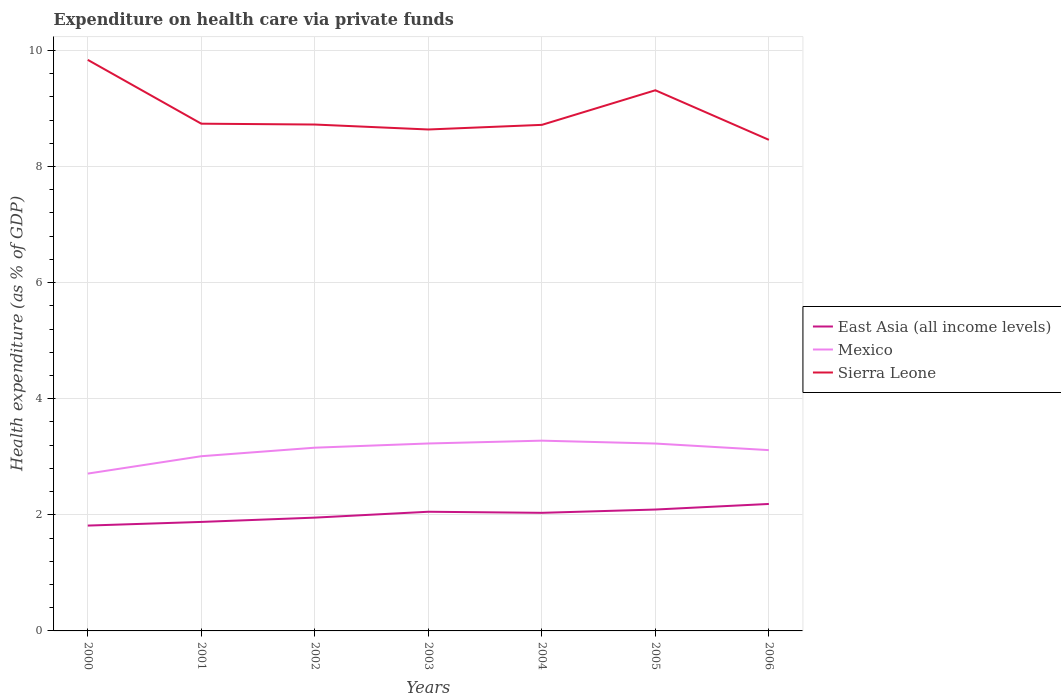How many different coloured lines are there?
Your answer should be very brief. 3. Across all years, what is the maximum expenditure made on health care in Sierra Leone?
Provide a short and direct response. 8.46. In which year was the expenditure made on health care in East Asia (all income levels) maximum?
Your response must be concise. 2000. What is the total expenditure made on health care in Sierra Leone in the graph?
Make the answer very short. -0.68. What is the difference between the highest and the second highest expenditure made on health care in Sierra Leone?
Provide a succinct answer. 1.38. How many lines are there?
Your answer should be compact. 3. Does the graph contain grids?
Offer a very short reply. Yes. Where does the legend appear in the graph?
Keep it short and to the point. Center right. How many legend labels are there?
Your answer should be compact. 3. How are the legend labels stacked?
Your answer should be very brief. Vertical. What is the title of the graph?
Provide a succinct answer. Expenditure on health care via private funds. Does "Libya" appear as one of the legend labels in the graph?
Your response must be concise. No. What is the label or title of the X-axis?
Offer a very short reply. Years. What is the label or title of the Y-axis?
Offer a very short reply. Health expenditure (as % of GDP). What is the Health expenditure (as % of GDP) of East Asia (all income levels) in 2000?
Ensure brevity in your answer.  1.81. What is the Health expenditure (as % of GDP) of Mexico in 2000?
Provide a succinct answer. 2.71. What is the Health expenditure (as % of GDP) of Sierra Leone in 2000?
Your answer should be very brief. 9.84. What is the Health expenditure (as % of GDP) of East Asia (all income levels) in 2001?
Your answer should be compact. 1.88. What is the Health expenditure (as % of GDP) in Mexico in 2001?
Offer a very short reply. 3.01. What is the Health expenditure (as % of GDP) in Sierra Leone in 2001?
Provide a short and direct response. 8.74. What is the Health expenditure (as % of GDP) in East Asia (all income levels) in 2002?
Offer a very short reply. 1.95. What is the Health expenditure (as % of GDP) in Mexico in 2002?
Your response must be concise. 3.16. What is the Health expenditure (as % of GDP) of Sierra Leone in 2002?
Give a very brief answer. 8.72. What is the Health expenditure (as % of GDP) of East Asia (all income levels) in 2003?
Your response must be concise. 2.05. What is the Health expenditure (as % of GDP) in Mexico in 2003?
Make the answer very short. 3.23. What is the Health expenditure (as % of GDP) of Sierra Leone in 2003?
Provide a succinct answer. 8.64. What is the Health expenditure (as % of GDP) in East Asia (all income levels) in 2004?
Your answer should be very brief. 2.03. What is the Health expenditure (as % of GDP) of Mexico in 2004?
Offer a terse response. 3.28. What is the Health expenditure (as % of GDP) in Sierra Leone in 2004?
Offer a very short reply. 8.72. What is the Health expenditure (as % of GDP) in East Asia (all income levels) in 2005?
Your answer should be compact. 2.09. What is the Health expenditure (as % of GDP) of Mexico in 2005?
Provide a succinct answer. 3.23. What is the Health expenditure (as % of GDP) in Sierra Leone in 2005?
Your answer should be very brief. 9.31. What is the Health expenditure (as % of GDP) of East Asia (all income levels) in 2006?
Offer a very short reply. 2.19. What is the Health expenditure (as % of GDP) in Mexico in 2006?
Your answer should be compact. 3.11. What is the Health expenditure (as % of GDP) in Sierra Leone in 2006?
Ensure brevity in your answer.  8.46. Across all years, what is the maximum Health expenditure (as % of GDP) of East Asia (all income levels)?
Your response must be concise. 2.19. Across all years, what is the maximum Health expenditure (as % of GDP) in Mexico?
Provide a succinct answer. 3.28. Across all years, what is the maximum Health expenditure (as % of GDP) of Sierra Leone?
Give a very brief answer. 9.84. Across all years, what is the minimum Health expenditure (as % of GDP) of East Asia (all income levels)?
Your answer should be compact. 1.81. Across all years, what is the minimum Health expenditure (as % of GDP) of Mexico?
Ensure brevity in your answer.  2.71. Across all years, what is the minimum Health expenditure (as % of GDP) in Sierra Leone?
Your answer should be very brief. 8.46. What is the total Health expenditure (as % of GDP) of East Asia (all income levels) in the graph?
Offer a terse response. 14.01. What is the total Health expenditure (as % of GDP) of Mexico in the graph?
Your response must be concise. 21.72. What is the total Health expenditure (as % of GDP) in Sierra Leone in the graph?
Provide a short and direct response. 62.42. What is the difference between the Health expenditure (as % of GDP) in East Asia (all income levels) in 2000 and that in 2001?
Ensure brevity in your answer.  -0.06. What is the difference between the Health expenditure (as % of GDP) in Mexico in 2000 and that in 2001?
Offer a terse response. -0.3. What is the difference between the Health expenditure (as % of GDP) in Sierra Leone in 2000 and that in 2001?
Give a very brief answer. 1.1. What is the difference between the Health expenditure (as % of GDP) in East Asia (all income levels) in 2000 and that in 2002?
Provide a short and direct response. -0.14. What is the difference between the Health expenditure (as % of GDP) of Mexico in 2000 and that in 2002?
Keep it short and to the point. -0.45. What is the difference between the Health expenditure (as % of GDP) of Sierra Leone in 2000 and that in 2002?
Make the answer very short. 1.11. What is the difference between the Health expenditure (as % of GDP) in East Asia (all income levels) in 2000 and that in 2003?
Ensure brevity in your answer.  -0.24. What is the difference between the Health expenditure (as % of GDP) of Mexico in 2000 and that in 2003?
Ensure brevity in your answer.  -0.52. What is the difference between the Health expenditure (as % of GDP) of Sierra Leone in 2000 and that in 2003?
Offer a terse response. 1.2. What is the difference between the Health expenditure (as % of GDP) of East Asia (all income levels) in 2000 and that in 2004?
Provide a short and direct response. -0.22. What is the difference between the Health expenditure (as % of GDP) in Mexico in 2000 and that in 2004?
Ensure brevity in your answer.  -0.57. What is the difference between the Health expenditure (as % of GDP) of Sierra Leone in 2000 and that in 2004?
Make the answer very short. 1.12. What is the difference between the Health expenditure (as % of GDP) of East Asia (all income levels) in 2000 and that in 2005?
Your answer should be very brief. -0.28. What is the difference between the Health expenditure (as % of GDP) in Mexico in 2000 and that in 2005?
Your response must be concise. -0.52. What is the difference between the Health expenditure (as % of GDP) in Sierra Leone in 2000 and that in 2005?
Your answer should be compact. 0.52. What is the difference between the Health expenditure (as % of GDP) of East Asia (all income levels) in 2000 and that in 2006?
Offer a very short reply. -0.37. What is the difference between the Health expenditure (as % of GDP) of Mexico in 2000 and that in 2006?
Provide a short and direct response. -0.4. What is the difference between the Health expenditure (as % of GDP) of Sierra Leone in 2000 and that in 2006?
Your answer should be compact. 1.38. What is the difference between the Health expenditure (as % of GDP) of East Asia (all income levels) in 2001 and that in 2002?
Give a very brief answer. -0.07. What is the difference between the Health expenditure (as % of GDP) in Mexico in 2001 and that in 2002?
Offer a very short reply. -0.15. What is the difference between the Health expenditure (as % of GDP) in Sierra Leone in 2001 and that in 2002?
Provide a succinct answer. 0.01. What is the difference between the Health expenditure (as % of GDP) in East Asia (all income levels) in 2001 and that in 2003?
Offer a terse response. -0.18. What is the difference between the Health expenditure (as % of GDP) in Mexico in 2001 and that in 2003?
Keep it short and to the point. -0.22. What is the difference between the Health expenditure (as % of GDP) of Sierra Leone in 2001 and that in 2003?
Your answer should be compact. 0.1. What is the difference between the Health expenditure (as % of GDP) of East Asia (all income levels) in 2001 and that in 2004?
Make the answer very short. -0.16. What is the difference between the Health expenditure (as % of GDP) in Mexico in 2001 and that in 2004?
Provide a succinct answer. -0.27. What is the difference between the Health expenditure (as % of GDP) in Sierra Leone in 2001 and that in 2004?
Your answer should be very brief. 0.02. What is the difference between the Health expenditure (as % of GDP) of East Asia (all income levels) in 2001 and that in 2005?
Ensure brevity in your answer.  -0.21. What is the difference between the Health expenditure (as % of GDP) of Mexico in 2001 and that in 2005?
Ensure brevity in your answer.  -0.22. What is the difference between the Health expenditure (as % of GDP) of Sierra Leone in 2001 and that in 2005?
Provide a short and direct response. -0.58. What is the difference between the Health expenditure (as % of GDP) of East Asia (all income levels) in 2001 and that in 2006?
Your response must be concise. -0.31. What is the difference between the Health expenditure (as % of GDP) in Mexico in 2001 and that in 2006?
Provide a succinct answer. -0.1. What is the difference between the Health expenditure (as % of GDP) of Sierra Leone in 2001 and that in 2006?
Offer a terse response. 0.28. What is the difference between the Health expenditure (as % of GDP) of East Asia (all income levels) in 2002 and that in 2003?
Ensure brevity in your answer.  -0.1. What is the difference between the Health expenditure (as % of GDP) in Mexico in 2002 and that in 2003?
Make the answer very short. -0.07. What is the difference between the Health expenditure (as % of GDP) in Sierra Leone in 2002 and that in 2003?
Ensure brevity in your answer.  0.09. What is the difference between the Health expenditure (as % of GDP) in East Asia (all income levels) in 2002 and that in 2004?
Offer a terse response. -0.08. What is the difference between the Health expenditure (as % of GDP) of Mexico in 2002 and that in 2004?
Make the answer very short. -0.12. What is the difference between the Health expenditure (as % of GDP) in Sierra Leone in 2002 and that in 2004?
Offer a very short reply. 0.01. What is the difference between the Health expenditure (as % of GDP) in East Asia (all income levels) in 2002 and that in 2005?
Your answer should be very brief. -0.14. What is the difference between the Health expenditure (as % of GDP) of Mexico in 2002 and that in 2005?
Your answer should be compact. -0.07. What is the difference between the Health expenditure (as % of GDP) of Sierra Leone in 2002 and that in 2005?
Provide a short and direct response. -0.59. What is the difference between the Health expenditure (as % of GDP) in East Asia (all income levels) in 2002 and that in 2006?
Offer a terse response. -0.24. What is the difference between the Health expenditure (as % of GDP) in Mexico in 2002 and that in 2006?
Ensure brevity in your answer.  0.04. What is the difference between the Health expenditure (as % of GDP) of Sierra Leone in 2002 and that in 2006?
Your response must be concise. 0.26. What is the difference between the Health expenditure (as % of GDP) of East Asia (all income levels) in 2003 and that in 2004?
Your answer should be very brief. 0.02. What is the difference between the Health expenditure (as % of GDP) in Mexico in 2003 and that in 2004?
Provide a short and direct response. -0.05. What is the difference between the Health expenditure (as % of GDP) in Sierra Leone in 2003 and that in 2004?
Your response must be concise. -0.08. What is the difference between the Health expenditure (as % of GDP) of East Asia (all income levels) in 2003 and that in 2005?
Ensure brevity in your answer.  -0.04. What is the difference between the Health expenditure (as % of GDP) in Mexico in 2003 and that in 2005?
Your answer should be very brief. 0. What is the difference between the Health expenditure (as % of GDP) of Sierra Leone in 2003 and that in 2005?
Offer a very short reply. -0.68. What is the difference between the Health expenditure (as % of GDP) of East Asia (all income levels) in 2003 and that in 2006?
Your answer should be compact. -0.13. What is the difference between the Health expenditure (as % of GDP) in Mexico in 2003 and that in 2006?
Keep it short and to the point. 0.11. What is the difference between the Health expenditure (as % of GDP) of Sierra Leone in 2003 and that in 2006?
Give a very brief answer. 0.18. What is the difference between the Health expenditure (as % of GDP) of East Asia (all income levels) in 2004 and that in 2005?
Offer a very short reply. -0.06. What is the difference between the Health expenditure (as % of GDP) of Mexico in 2004 and that in 2005?
Ensure brevity in your answer.  0.05. What is the difference between the Health expenditure (as % of GDP) in Sierra Leone in 2004 and that in 2005?
Give a very brief answer. -0.6. What is the difference between the Health expenditure (as % of GDP) in East Asia (all income levels) in 2004 and that in 2006?
Provide a succinct answer. -0.15. What is the difference between the Health expenditure (as % of GDP) of Mexico in 2004 and that in 2006?
Make the answer very short. 0.16. What is the difference between the Health expenditure (as % of GDP) in Sierra Leone in 2004 and that in 2006?
Your response must be concise. 0.26. What is the difference between the Health expenditure (as % of GDP) of East Asia (all income levels) in 2005 and that in 2006?
Your response must be concise. -0.1. What is the difference between the Health expenditure (as % of GDP) in Mexico in 2005 and that in 2006?
Offer a very short reply. 0.11. What is the difference between the Health expenditure (as % of GDP) of Sierra Leone in 2005 and that in 2006?
Provide a succinct answer. 0.85. What is the difference between the Health expenditure (as % of GDP) in East Asia (all income levels) in 2000 and the Health expenditure (as % of GDP) in Mexico in 2001?
Give a very brief answer. -1.19. What is the difference between the Health expenditure (as % of GDP) in East Asia (all income levels) in 2000 and the Health expenditure (as % of GDP) in Sierra Leone in 2001?
Give a very brief answer. -6.92. What is the difference between the Health expenditure (as % of GDP) of Mexico in 2000 and the Health expenditure (as % of GDP) of Sierra Leone in 2001?
Ensure brevity in your answer.  -6.03. What is the difference between the Health expenditure (as % of GDP) of East Asia (all income levels) in 2000 and the Health expenditure (as % of GDP) of Mexico in 2002?
Give a very brief answer. -1.34. What is the difference between the Health expenditure (as % of GDP) in East Asia (all income levels) in 2000 and the Health expenditure (as % of GDP) in Sierra Leone in 2002?
Your response must be concise. -6.91. What is the difference between the Health expenditure (as % of GDP) in Mexico in 2000 and the Health expenditure (as % of GDP) in Sierra Leone in 2002?
Keep it short and to the point. -6.01. What is the difference between the Health expenditure (as % of GDP) in East Asia (all income levels) in 2000 and the Health expenditure (as % of GDP) in Mexico in 2003?
Your answer should be compact. -1.41. What is the difference between the Health expenditure (as % of GDP) in East Asia (all income levels) in 2000 and the Health expenditure (as % of GDP) in Sierra Leone in 2003?
Provide a short and direct response. -6.82. What is the difference between the Health expenditure (as % of GDP) in Mexico in 2000 and the Health expenditure (as % of GDP) in Sierra Leone in 2003?
Your answer should be very brief. -5.93. What is the difference between the Health expenditure (as % of GDP) of East Asia (all income levels) in 2000 and the Health expenditure (as % of GDP) of Mexico in 2004?
Give a very brief answer. -1.46. What is the difference between the Health expenditure (as % of GDP) of East Asia (all income levels) in 2000 and the Health expenditure (as % of GDP) of Sierra Leone in 2004?
Provide a short and direct response. -6.9. What is the difference between the Health expenditure (as % of GDP) in Mexico in 2000 and the Health expenditure (as % of GDP) in Sierra Leone in 2004?
Ensure brevity in your answer.  -6.01. What is the difference between the Health expenditure (as % of GDP) of East Asia (all income levels) in 2000 and the Health expenditure (as % of GDP) of Mexico in 2005?
Make the answer very short. -1.41. What is the difference between the Health expenditure (as % of GDP) of East Asia (all income levels) in 2000 and the Health expenditure (as % of GDP) of Sierra Leone in 2005?
Offer a very short reply. -7.5. What is the difference between the Health expenditure (as % of GDP) of Mexico in 2000 and the Health expenditure (as % of GDP) of Sierra Leone in 2005?
Provide a succinct answer. -6.6. What is the difference between the Health expenditure (as % of GDP) of East Asia (all income levels) in 2000 and the Health expenditure (as % of GDP) of Mexico in 2006?
Your answer should be very brief. -1.3. What is the difference between the Health expenditure (as % of GDP) in East Asia (all income levels) in 2000 and the Health expenditure (as % of GDP) in Sierra Leone in 2006?
Give a very brief answer. -6.64. What is the difference between the Health expenditure (as % of GDP) in Mexico in 2000 and the Health expenditure (as % of GDP) in Sierra Leone in 2006?
Provide a short and direct response. -5.75. What is the difference between the Health expenditure (as % of GDP) in East Asia (all income levels) in 2001 and the Health expenditure (as % of GDP) in Mexico in 2002?
Provide a short and direct response. -1.28. What is the difference between the Health expenditure (as % of GDP) in East Asia (all income levels) in 2001 and the Health expenditure (as % of GDP) in Sierra Leone in 2002?
Your response must be concise. -6.84. What is the difference between the Health expenditure (as % of GDP) of Mexico in 2001 and the Health expenditure (as % of GDP) of Sierra Leone in 2002?
Offer a very short reply. -5.71. What is the difference between the Health expenditure (as % of GDP) of East Asia (all income levels) in 2001 and the Health expenditure (as % of GDP) of Mexico in 2003?
Your response must be concise. -1.35. What is the difference between the Health expenditure (as % of GDP) of East Asia (all income levels) in 2001 and the Health expenditure (as % of GDP) of Sierra Leone in 2003?
Your answer should be compact. -6.76. What is the difference between the Health expenditure (as % of GDP) in Mexico in 2001 and the Health expenditure (as % of GDP) in Sierra Leone in 2003?
Your answer should be compact. -5.63. What is the difference between the Health expenditure (as % of GDP) in East Asia (all income levels) in 2001 and the Health expenditure (as % of GDP) in Mexico in 2004?
Give a very brief answer. -1.4. What is the difference between the Health expenditure (as % of GDP) in East Asia (all income levels) in 2001 and the Health expenditure (as % of GDP) in Sierra Leone in 2004?
Give a very brief answer. -6.84. What is the difference between the Health expenditure (as % of GDP) of Mexico in 2001 and the Health expenditure (as % of GDP) of Sierra Leone in 2004?
Provide a succinct answer. -5.71. What is the difference between the Health expenditure (as % of GDP) of East Asia (all income levels) in 2001 and the Health expenditure (as % of GDP) of Mexico in 2005?
Give a very brief answer. -1.35. What is the difference between the Health expenditure (as % of GDP) in East Asia (all income levels) in 2001 and the Health expenditure (as % of GDP) in Sierra Leone in 2005?
Your answer should be very brief. -7.43. What is the difference between the Health expenditure (as % of GDP) of Mexico in 2001 and the Health expenditure (as % of GDP) of Sierra Leone in 2005?
Ensure brevity in your answer.  -6.3. What is the difference between the Health expenditure (as % of GDP) in East Asia (all income levels) in 2001 and the Health expenditure (as % of GDP) in Mexico in 2006?
Your answer should be compact. -1.24. What is the difference between the Health expenditure (as % of GDP) in East Asia (all income levels) in 2001 and the Health expenditure (as % of GDP) in Sierra Leone in 2006?
Keep it short and to the point. -6.58. What is the difference between the Health expenditure (as % of GDP) of Mexico in 2001 and the Health expenditure (as % of GDP) of Sierra Leone in 2006?
Your answer should be very brief. -5.45. What is the difference between the Health expenditure (as % of GDP) in East Asia (all income levels) in 2002 and the Health expenditure (as % of GDP) in Mexico in 2003?
Keep it short and to the point. -1.28. What is the difference between the Health expenditure (as % of GDP) in East Asia (all income levels) in 2002 and the Health expenditure (as % of GDP) in Sierra Leone in 2003?
Provide a succinct answer. -6.69. What is the difference between the Health expenditure (as % of GDP) of Mexico in 2002 and the Health expenditure (as % of GDP) of Sierra Leone in 2003?
Offer a terse response. -5.48. What is the difference between the Health expenditure (as % of GDP) of East Asia (all income levels) in 2002 and the Health expenditure (as % of GDP) of Mexico in 2004?
Your answer should be compact. -1.33. What is the difference between the Health expenditure (as % of GDP) in East Asia (all income levels) in 2002 and the Health expenditure (as % of GDP) in Sierra Leone in 2004?
Ensure brevity in your answer.  -6.76. What is the difference between the Health expenditure (as % of GDP) of Mexico in 2002 and the Health expenditure (as % of GDP) of Sierra Leone in 2004?
Give a very brief answer. -5.56. What is the difference between the Health expenditure (as % of GDP) of East Asia (all income levels) in 2002 and the Health expenditure (as % of GDP) of Mexico in 2005?
Keep it short and to the point. -1.28. What is the difference between the Health expenditure (as % of GDP) in East Asia (all income levels) in 2002 and the Health expenditure (as % of GDP) in Sierra Leone in 2005?
Your answer should be very brief. -7.36. What is the difference between the Health expenditure (as % of GDP) of Mexico in 2002 and the Health expenditure (as % of GDP) of Sierra Leone in 2005?
Provide a short and direct response. -6.16. What is the difference between the Health expenditure (as % of GDP) in East Asia (all income levels) in 2002 and the Health expenditure (as % of GDP) in Mexico in 2006?
Provide a short and direct response. -1.16. What is the difference between the Health expenditure (as % of GDP) in East Asia (all income levels) in 2002 and the Health expenditure (as % of GDP) in Sierra Leone in 2006?
Offer a very short reply. -6.51. What is the difference between the Health expenditure (as % of GDP) in Mexico in 2002 and the Health expenditure (as % of GDP) in Sierra Leone in 2006?
Your answer should be compact. -5.3. What is the difference between the Health expenditure (as % of GDP) of East Asia (all income levels) in 2003 and the Health expenditure (as % of GDP) of Mexico in 2004?
Your answer should be very brief. -1.22. What is the difference between the Health expenditure (as % of GDP) of East Asia (all income levels) in 2003 and the Health expenditure (as % of GDP) of Sierra Leone in 2004?
Make the answer very short. -6.66. What is the difference between the Health expenditure (as % of GDP) of Mexico in 2003 and the Health expenditure (as % of GDP) of Sierra Leone in 2004?
Your response must be concise. -5.49. What is the difference between the Health expenditure (as % of GDP) of East Asia (all income levels) in 2003 and the Health expenditure (as % of GDP) of Mexico in 2005?
Give a very brief answer. -1.17. What is the difference between the Health expenditure (as % of GDP) in East Asia (all income levels) in 2003 and the Health expenditure (as % of GDP) in Sierra Leone in 2005?
Make the answer very short. -7.26. What is the difference between the Health expenditure (as % of GDP) of Mexico in 2003 and the Health expenditure (as % of GDP) of Sierra Leone in 2005?
Your response must be concise. -6.08. What is the difference between the Health expenditure (as % of GDP) of East Asia (all income levels) in 2003 and the Health expenditure (as % of GDP) of Mexico in 2006?
Your response must be concise. -1.06. What is the difference between the Health expenditure (as % of GDP) of East Asia (all income levels) in 2003 and the Health expenditure (as % of GDP) of Sierra Leone in 2006?
Keep it short and to the point. -6.41. What is the difference between the Health expenditure (as % of GDP) of Mexico in 2003 and the Health expenditure (as % of GDP) of Sierra Leone in 2006?
Offer a terse response. -5.23. What is the difference between the Health expenditure (as % of GDP) in East Asia (all income levels) in 2004 and the Health expenditure (as % of GDP) in Mexico in 2005?
Your response must be concise. -1.19. What is the difference between the Health expenditure (as % of GDP) of East Asia (all income levels) in 2004 and the Health expenditure (as % of GDP) of Sierra Leone in 2005?
Offer a very short reply. -7.28. What is the difference between the Health expenditure (as % of GDP) of Mexico in 2004 and the Health expenditure (as % of GDP) of Sierra Leone in 2005?
Your answer should be very brief. -6.04. What is the difference between the Health expenditure (as % of GDP) of East Asia (all income levels) in 2004 and the Health expenditure (as % of GDP) of Mexico in 2006?
Offer a terse response. -1.08. What is the difference between the Health expenditure (as % of GDP) in East Asia (all income levels) in 2004 and the Health expenditure (as % of GDP) in Sierra Leone in 2006?
Provide a short and direct response. -6.42. What is the difference between the Health expenditure (as % of GDP) of Mexico in 2004 and the Health expenditure (as % of GDP) of Sierra Leone in 2006?
Make the answer very short. -5.18. What is the difference between the Health expenditure (as % of GDP) of East Asia (all income levels) in 2005 and the Health expenditure (as % of GDP) of Mexico in 2006?
Offer a terse response. -1.02. What is the difference between the Health expenditure (as % of GDP) in East Asia (all income levels) in 2005 and the Health expenditure (as % of GDP) in Sierra Leone in 2006?
Provide a succinct answer. -6.37. What is the difference between the Health expenditure (as % of GDP) in Mexico in 2005 and the Health expenditure (as % of GDP) in Sierra Leone in 2006?
Provide a short and direct response. -5.23. What is the average Health expenditure (as % of GDP) of East Asia (all income levels) per year?
Make the answer very short. 2. What is the average Health expenditure (as % of GDP) in Mexico per year?
Ensure brevity in your answer.  3.1. What is the average Health expenditure (as % of GDP) of Sierra Leone per year?
Offer a terse response. 8.92. In the year 2000, what is the difference between the Health expenditure (as % of GDP) in East Asia (all income levels) and Health expenditure (as % of GDP) in Mexico?
Ensure brevity in your answer.  -0.9. In the year 2000, what is the difference between the Health expenditure (as % of GDP) in East Asia (all income levels) and Health expenditure (as % of GDP) in Sierra Leone?
Make the answer very short. -8.02. In the year 2000, what is the difference between the Health expenditure (as % of GDP) of Mexico and Health expenditure (as % of GDP) of Sierra Leone?
Your answer should be compact. -7.13. In the year 2001, what is the difference between the Health expenditure (as % of GDP) of East Asia (all income levels) and Health expenditure (as % of GDP) of Mexico?
Provide a succinct answer. -1.13. In the year 2001, what is the difference between the Health expenditure (as % of GDP) in East Asia (all income levels) and Health expenditure (as % of GDP) in Sierra Leone?
Your answer should be compact. -6.86. In the year 2001, what is the difference between the Health expenditure (as % of GDP) in Mexico and Health expenditure (as % of GDP) in Sierra Leone?
Your answer should be very brief. -5.73. In the year 2002, what is the difference between the Health expenditure (as % of GDP) in East Asia (all income levels) and Health expenditure (as % of GDP) in Mexico?
Ensure brevity in your answer.  -1.2. In the year 2002, what is the difference between the Health expenditure (as % of GDP) of East Asia (all income levels) and Health expenditure (as % of GDP) of Sierra Leone?
Give a very brief answer. -6.77. In the year 2002, what is the difference between the Health expenditure (as % of GDP) in Mexico and Health expenditure (as % of GDP) in Sierra Leone?
Keep it short and to the point. -5.57. In the year 2003, what is the difference between the Health expenditure (as % of GDP) in East Asia (all income levels) and Health expenditure (as % of GDP) in Mexico?
Offer a terse response. -1.18. In the year 2003, what is the difference between the Health expenditure (as % of GDP) of East Asia (all income levels) and Health expenditure (as % of GDP) of Sierra Leone?
Your response must be concise. -6.58. In the year 2003, what is the difference between the Health expenditure (as % of GDP) of Mexico and Health expenditure (as % of GDP) of Sierra Leone?
Offer a terse response. -5.41. In the year 2004, what is the difference between the Health expenditure (as % of GDP) in East Asia (all income levels) and Health expenditure (as % of GDP) in Mexico?
Provide a short and direct response. -1.24. In the year 2004, what is the difference between the Health expenditure (as % of GDP) of East Asia (all income levels) and Health expenditure (as % of GDP) of Sierra Leone?
Give a very brief answer. -6.68. In the year 2004, what is the difference between the Health expenditure (as % of GDP) of Mexico and Health expenditure (as % of GDP) of Sierra Leone?
Ensure brevity in your answer.  -5.44. In the year 2005, what is the difference between the Health expenditure (as % of GDP) of East Asia (all income levels) and Health expenditure (as % of GDP) of Mexico?
Make the answer very short. -1.14. In the year 2005, what is the difference between the Health expenditure (as % of GDP) of East Asia (all income levels) and Health expenditure (as % of GDP) of Sierra Leone?
Provide a short and direct response. -7.22. In the year 2005, what is the difference between the Health expenditure (as % of GDP) of Mexico and Health expenditure (as % of GDP) of Sierra Leone?
Your answer should be very brief. -6.08. In the year 2006, what is the difference between the Health expenditure (as % of GDP) of East Asia (all income levels) and Health expenditure (as % of GDP) of Mexico?
Your answer should be very brief. -0.93. In the year 2006, what is the difference between the Health expenditure (as % of GDP) in East Asia (all income levels) and Health expenditure (as % of GDP) in Sierra Leone?
Your answer should be compact. -6.27. In the year 2006, what is the difference between the Health expenditure (as % of GDP) of Mexico and Health expenditure (as % of GDP) of Sierra Leone?
Offer a very short reply. -5.34. What is the ratio of the Health expenditure (as % of GDP) in East Asia (all income levels) in 2000 to that in 2001?
Keep it short and to the point. 0.97. What is the ratio of the Health expenditure (as % of GDP) of Mexico in 2000 to that in 2001?
Your answer should be compact. 0.9. What is the ratio of the Health expenditure (as % of GDP) of Sierra Leone in 2000 to that in 2001?
Ensure brevity in your answer.  1.13. What is the ratio of the Health expenditure (as % of GDP) in East Asia (all income levels) in 2000 to that in 2002?
Your response must be concise. 0.93. What is the ratio of the Health expenditure (as % of GDP) in Mexico in 2000 to that in 2002?
Your response must be concise. 0.86. What is the ratio of the Health expenditure (as % of GDP) of Sierra Leone in 2000 to that in 2002?
Your answer should be compact. 1.13. What is the ratio of the Health expenditure (as % of GDP) of East Asia (all income levels) in 2000 to that in 2003?
Provide a succinct answer. 0.88. What is the ratio of the Health expenditure (as % of GDP) in Mexico in 2000 to that in 2003?
Your response must be concise. 0.84. What is the ratio of the Health expenditure (as % of GDP) of Sierra Leone in 2000 to that in 2003?
Provide a succinct answer. 1.14. What is the ratio of the Health expenditure (as % of GDP) of East Asia (all income levels) in 2000 to that in 2004?
Offer a terse response. 0.89. What is the ratio of the Health expenditure (as % of GDP) of Mexico in 2000 to that in 2004?
Give a very brief answer. 0.83. What is the ratio of the Health expenditure (as % of GDP) of Sierra Leone in 2000 to that in 2004?
Provide a short and direct response. 1.13. What is the ratio of the Health expenditure (as % of GDP) in East Asia (all income levels) in 2000 to that in 2005?
Provide a short and direct response. 0.87. What is the ratio of the Health expenditure (as % of GDP) of Mexico in 2000 to that in 2005?
Your answer should be very brief. 0.84. What is the ratio of the Health expenditure (as % of GDP) in Sierra Leone in 2000 to that in 2005?
Your answer should be very brief. 1.06. What is the ratio of the Health expenditure (as % of GDP) in East Asia (all income levels) in 2000 to that in 2006?
Provide a succinct answer. 0.83. What is the ratio of the Health expenditure (as % of GDP) of Mexico in 2000 to that in 2006?
Offer a terse response. 0.87. What is the ratio of the Health expenditure (as % of GDP) in Sierra Leone in 2000 to that in 2006?
Provide a short and direct response. 1.16. What is the ratio of the Health expenditure (as % of GDP) in East Asia (all income levels) in 2001 to that in 2002?
Offer a very short reply. 0.96. What is the ratio of the Health expenditure (as % of GDP) of Mexico in 2001 to that in 2002?
Your response must be concise. 0.95. What is the ratio of the Health expenditure (as % of GDP) of East Asia (all income levels) in 2001 to that in 2003?
Your answer should be compact. 0.91. What is the ratio of the Health expenditure (as % of GDP) in Mexico in 2001 to that in 2003?
Your answer should be very brief. 0.93. What is the ratio of the Health expenditure (as % of GDP) of Sierra Leone in 2001 to that in 2003?
Give a very brief answer. 1.01. What is the ratio of the Health expenditure (as % of GDP) in East Asia (all income levels) in 2001 to that in 2004?
Make the answer very short. 0.92. What is the ratio of the Health expenditure (as % of GDP) of Mexico in 2001 to that in 2004?
Make the answer very short. 0.92. What is the ratio of the Health expenditure (as % of GDP) of Sierra Leone in 2001 to that in 2004?
Make the answer very short. 1. What is the ratio of the Health expenditure (as % of GDP) in East Asia (all income levels) in 2001 to that in 2005?
Offer a very short reply. 0.9. What is the ratio of the Health expenditure (as % of GDP) of Mexico in 2001 to that in 2005?
Provide a short and direct response. 0.93. What is the ratio of the Health expenditure (as % of GDP) in Sierra Leone in 2001 to that in 2005?
Provide a succinct answer. 0.94. What is the ratio of the Health expenditure (as % of GDP) of East Asia (all income levels) in 2001 to that in 2006?
Your response must be concise. 0.86. What is the ratio of the Health expenditure (as % of GDP) in Mexico in 2001 to that in 2006?
Offer a terse response. 0.97. What is the ratio of the Health expenditure (as % of GDP) in Sierra Leone in 2001 to that in 2006?
Offer a terse response. 1.03. What is the ratio of the Health expenditure (as % of GDP) in East Asia (all income levels) in 2002 to that in 2003?
Your answer should be very brief. 0.95. What is the ratio of the Health expenditure (as % of GDP) in Mexico in 2002 to that in 2003?
Ensure brevity in your answer.  0.98. What is the ratio of the Health expenditure (as % of GDP) in Sierra Leone in 2002 to that in 2003?
Give a very brief answer. 1.01. What is the ratio of the Health expenditure (as % of GDP) of East Asia (all income levels) in 2002 to that in 2004?
Provide a short and direct response. 0.96. What is the ratio of the Health expenditure (as % of GDP) in Mexico in 2002 to that in 2004?
Offer a very short reply. 0.96. What is the ratio of the Health expenditure (as % of GDP) of Sierra Leone in 2002 to that in 2004?
Your answer should be compact. 1. What is the ratio of the Health expenditure (as % of GDP) of East Asia (all income levels) in 2002 to that in 2005?
Provide a succinct answer. 0.93. What is the ratio of the Health expenditure (as % of GDP) of Mexico in 2002 to that in 2005?
Ensure brevity in your answer.  0.98. What is the ratio of the Health expenditure (as % of GDP) in Sierra Leone in 2002 to that in 2005?
Your response must be concise. 0.94. What is the ratio of the Health expenditure (as % of GDP) of East Asia (all income levels) in 2002 to that in 2006?
Provide a succinct answer. 0.89. What is the ratio of the Health expenditure (as % of GDP) in Mexico in 2002 to that in 2006?
Offer a very short reply. 1.01. What is the ratio of the Health expenditure (as % of GDP) of Sierra Leone in 2002 to that in 2006?
Offer a terse response. 1.03. What is the ratio of the Health expenditure (as % of GDP) in East Asia (all income levels) in 2003 to that in 2004?
Provide a succinct answer. 1.01. What is the ratio of the Health expenditure (as % of GDP) of Mexico in 2003 to that in 2004?
Your answer should be compact. 0.99. What is the ratio of the Health expenditure (as % of GDP) in Sierra Leone in 2003 to that in 2004?
Make the answer very short. 0.99. What is the ratio of the Health expenditure (as % of GDP) of East Asia (all income levels) in 2003 to that in 2005?
Make the answer very short. 0.98. What is the ratio of the Health expenditure (as % of GDP) of Mexico in 2003 to that in 2005?
Provide a succinct answer. 1. What is the ratio of the Health expenditure (as % of GDP) of Sierra Leone in 2003 to that in 2005?
Offer a very short reply. 0.93. What is the ratio of the Health expenditure (as % of GDP) of East Asia (all income levels) in 2003 to that in 2006?
Give a very brief answer. 0.94. What is the ratio of the Health expenditure (as % of GDP) in Mexico in 2003 to that in 2006?
Provide a succinct answer. 1.04. What is the ratio of the Health expenditure (as % of GDP) in Sierra Leone in 2003 to that in 2006?
Provide a succinct answer. 1.02. What is the ratio of the Health expenditure (as % of GDP) in East Asia (all income levels) in 2004 to that in 2005?
Ensure brevity in your answer.  0.97. What is the ratio of the Health expenditure (as % of GDP) of Mexico in 2004 to that in 2005?
Your response must be concise. 1.02. What is the ratio of the Health expenditure (as % of GDP) of Sierra Leone in 2004 to that in 2005?
Offer a very short reply. 0.94. What is the ratio of the Health expenditure (as % of GDP) of East Asia (all income levels) in 2004 to that in 2006?
Offer a terse response. 0.93. What is the ratio of the Health expenditure (as % of GDP) of Mexico in 2004 to that in 2006?
Ensure brevity in your answer.  1.05. What is the ratio of the Health expenditure (as % of GDP) of Sierra Leone in 2004 to that in 2006?
Your response must be concise. 1.03. What is the ratio of the Health expenditure (as % of GDP) of East Asia (all income levels) in 2005 to that in 2006?
Your answer should be compact. 0.96. What is the ratio of the Health expenditure (as % of GDP) in Mexico in 2005 to that in 2006?
Your response must be concise. 1.04. What is the ratio of the Health expenditure (as % of GDP) in Sierra Leone in 2005 to that in 2006?
Offer a very short reply. 1.1. What is the difference between the highest and the second highest Health expenditure (as % of GDP) in East Asia (all income levels)?
Provide a succinct answer. 0.1. What is the difference between the highest and the second highest Health expenditure (as % of GDP) of Mexico?
Your answer should be very brief. 0.05. What is the difference between the highest and the second highest Health expenditure (as % of GDP) in Sierra Leone?
Offer a very short reply. 0.52. What is the difference between the highest and the lowest Health expenditure (as % of GDP) of East Asia (all income levels)?
Ensure brevity in your answer.  0.37. What is the difference between the highest and the lowest Health expenditure (as % of GDP) in Mexico?
Your response must be concise. 0.57. What is the difference between the highest and the lowest Health expenditure (as % of GDP) in Sierra Leone?
Offer a very short reply. 1.38. 